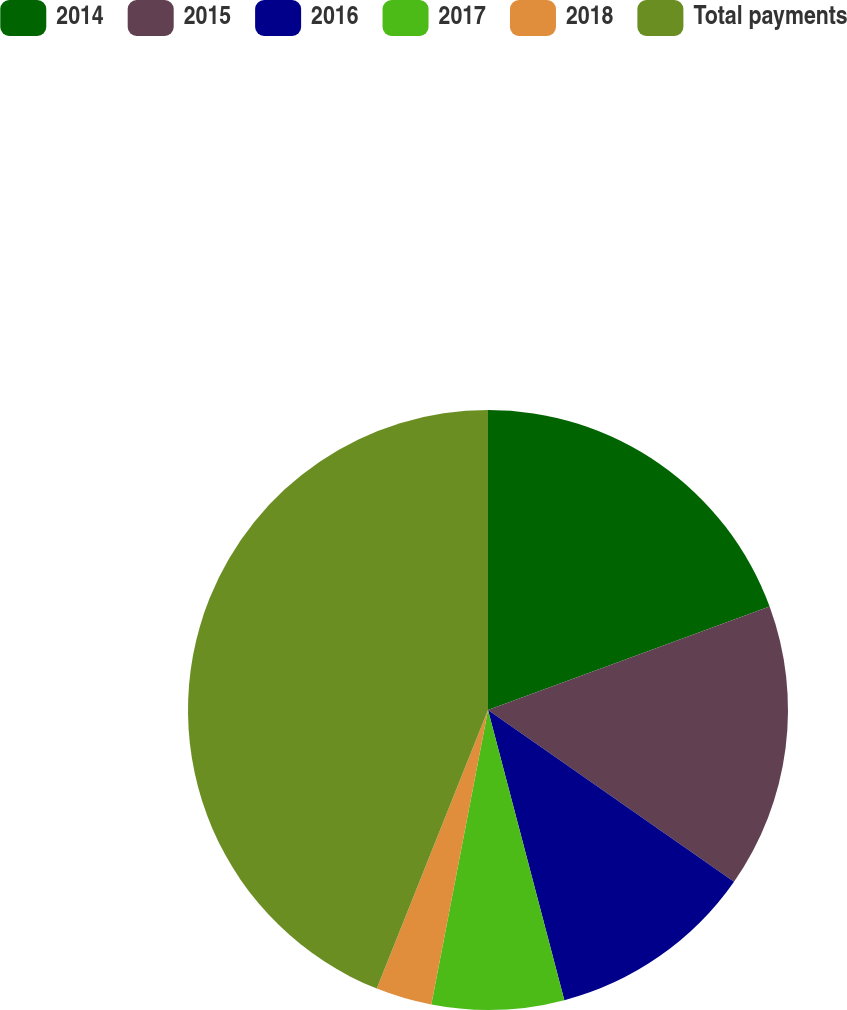Convert chart. <chart><loc_0><loc_0><loc_500><loc_500><pie_chart><fcel>2014<fcel>2015<fcel>2016<fcel>2017<fcel>2018<fcel>Total payments<nl><fcel>19.4%<fcel>15.3%<fcel>11.21%<fcel>7.12%<fcel>3.02%<fcel>43.96%<nl></chart> 